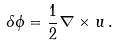Convert formula to latex. <formula><loc_0><loc_0><loc_500><loc_500>\delta { \phi } = \frac { 1 } { 2 } { \nabla } \times { u } \, .</formula> 